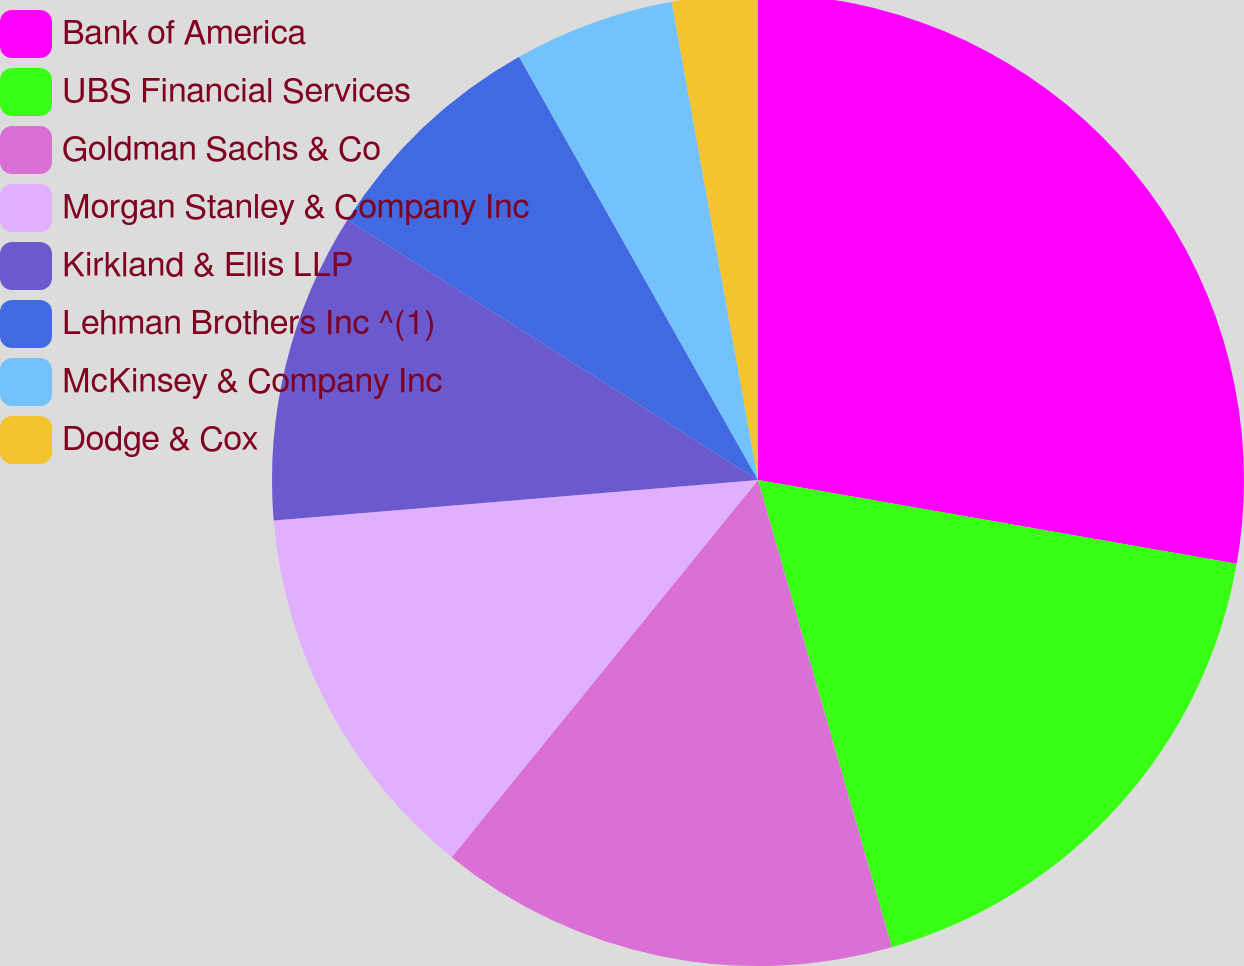<chart> <loc_0><loc_0><loc_500><loc_500><pie_chart><fcel>Bank of America<fcel>UBS Financial Services<fcel>Goldman Sachs & Co<fcel>Morgan Stanley & Company Inc<fcel>Kirkland & Ellis LLP<fcel>Lehman Brothers Inc ^(1)<fcel>McKinsey & Company Inc<fcel>Dodge & Cox<nl><fcel>27.76%<fcel>17.8%<fcel>15.3%<fcel>12.81%<fcel>10.32%<fcel>7.83%<fcel>5.34%<fcel>2.84%<nl></chart> 